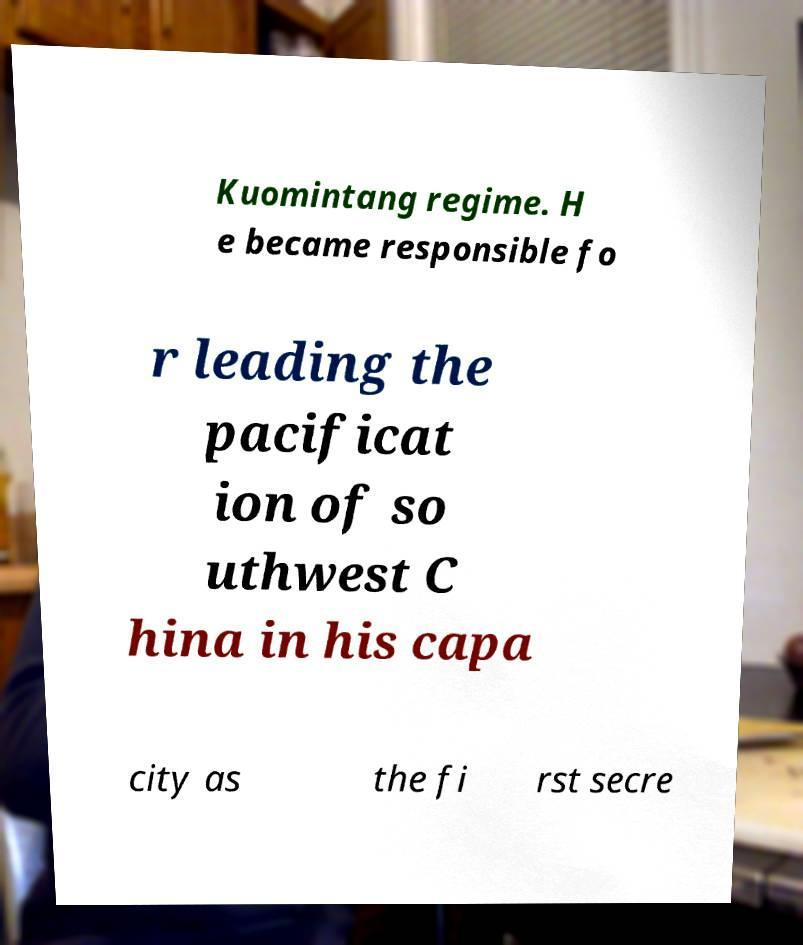Please identify and transcribe the text found in this image. Kuomintang regime. H e became responsible fo r leading the pacificat ion of so uthwest C hina in his capa city as the fi rst secre 